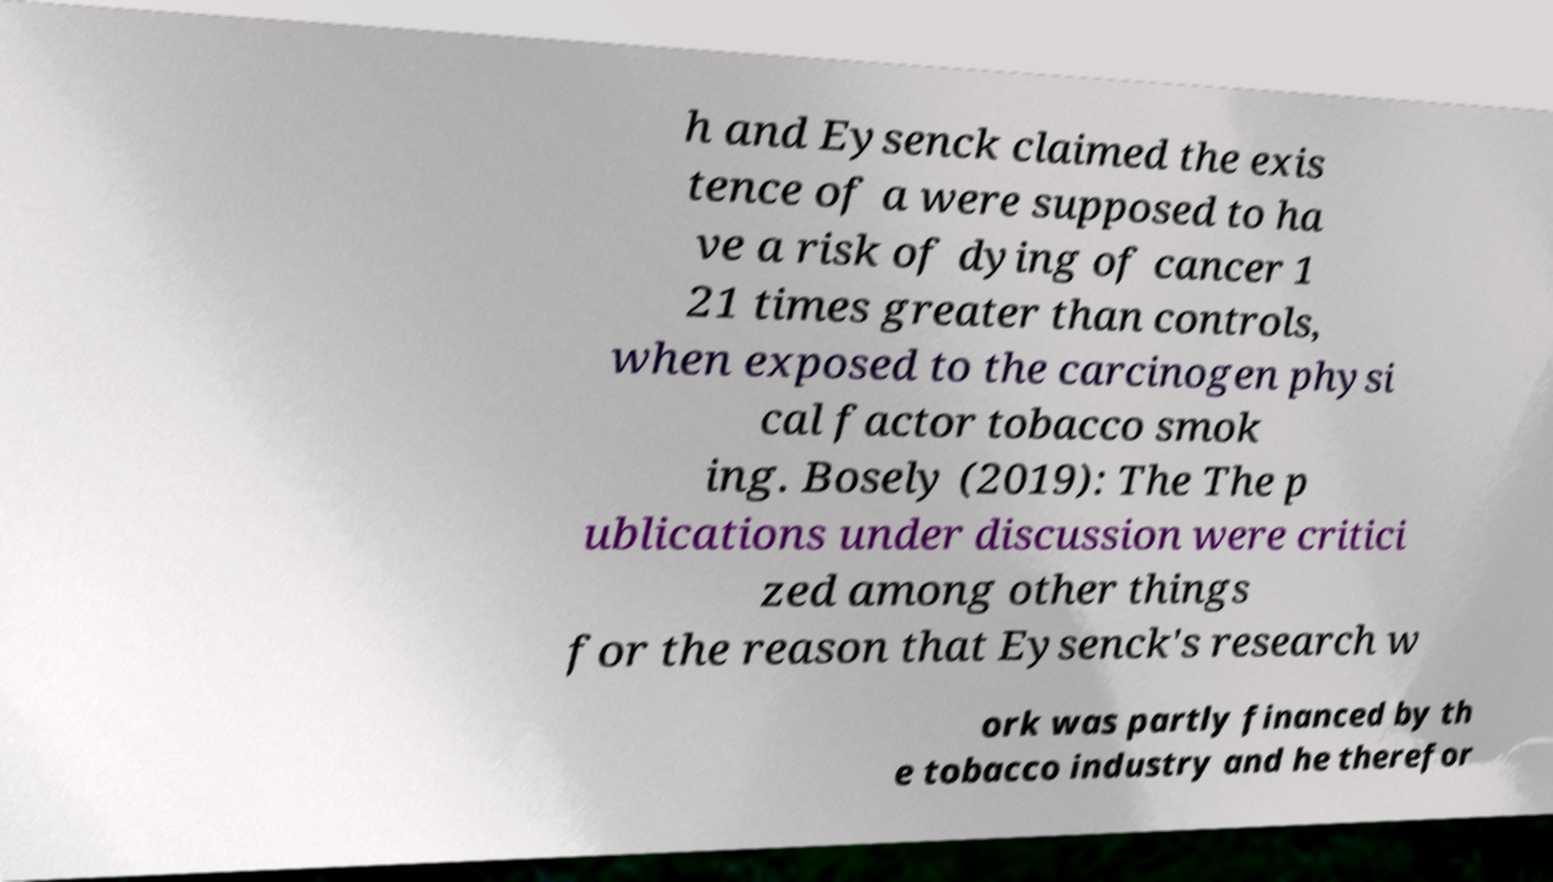For documentation purposes, I need the text within this image transcribed. Could you provide that? h and Eysenck claimed the exis tence of a were supposed to ha ve a risk of dying of cancer 1 21 times greater than controls, when exposed to the carcinogen physi cal factor tobacco smok ing. Bosely (2019): The The p ublications under discussion were critici zed among other things for the reason that Eysenck's research w ork was partly financed by th e tobacco industry and he therefor 